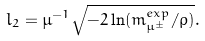<formula> <loc_0><loc_0><loc_500><loc_500>l _ { 2 } = \mu ^ { - 1 } \sqrt { - 2 \ln ( m ^ { e x p } _ { \mu ^ { \pm } } / \rho ) } .</formula> 